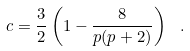Convert formula to latex. <formula><loc_0><loc_0><loc_500><loc_500>c = \frac { 3 } { 2 } \left ( 1 - \frac { 8 } { p ( p + 2 ) } \right ) \ .</formula> 